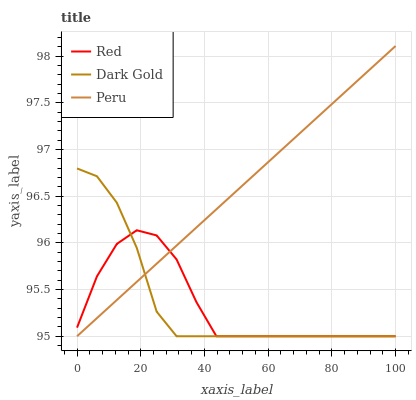Does Red have the minimum area under the curve?
Answer yes or no. Yes. Does Peru have the maximum area under the curve?
Answer yes or no. Yes. Does Dark Gold have the minimum area under the curve?
Answer yes or no. No. Does Dark Gold have the maximum area under the curve?
Answer yes or no. No. Is Peru the smoothest?
Answer yes or no. Yes. Is Red the roughest?
Answer yes or no. Yes. Is Dark Gold the smoothest?
Answer yes or no. No. Is Dark Gold the roughest?
Answer yes or no. No. Does Peru have the lowest value?
Answer yes or no. Yes. Does Peru have the highest value?
Answer yes or no. Yes. Does Dark Gold have the highest value?
Answer yes or no. No. Does Dark Gold intersect Red?
Answer yes or no. Yes. Is Dark Gold less than Red?
Answer yes or no. No. Is Dark Gold greater than Red?
Answer yes or no. No. 